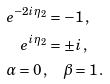Convert formula to latex. <formula><loc_0><loc_0><loc_500><loc_500>e ^ { - 2 i \eta _ { 2 } } & = - 1 \, , \\ e ^ { i \eta _ { 2 } } & = \pm i \, , \\ \alpha = 0 \, , & \quad \beta = 1 \, .</formula> 